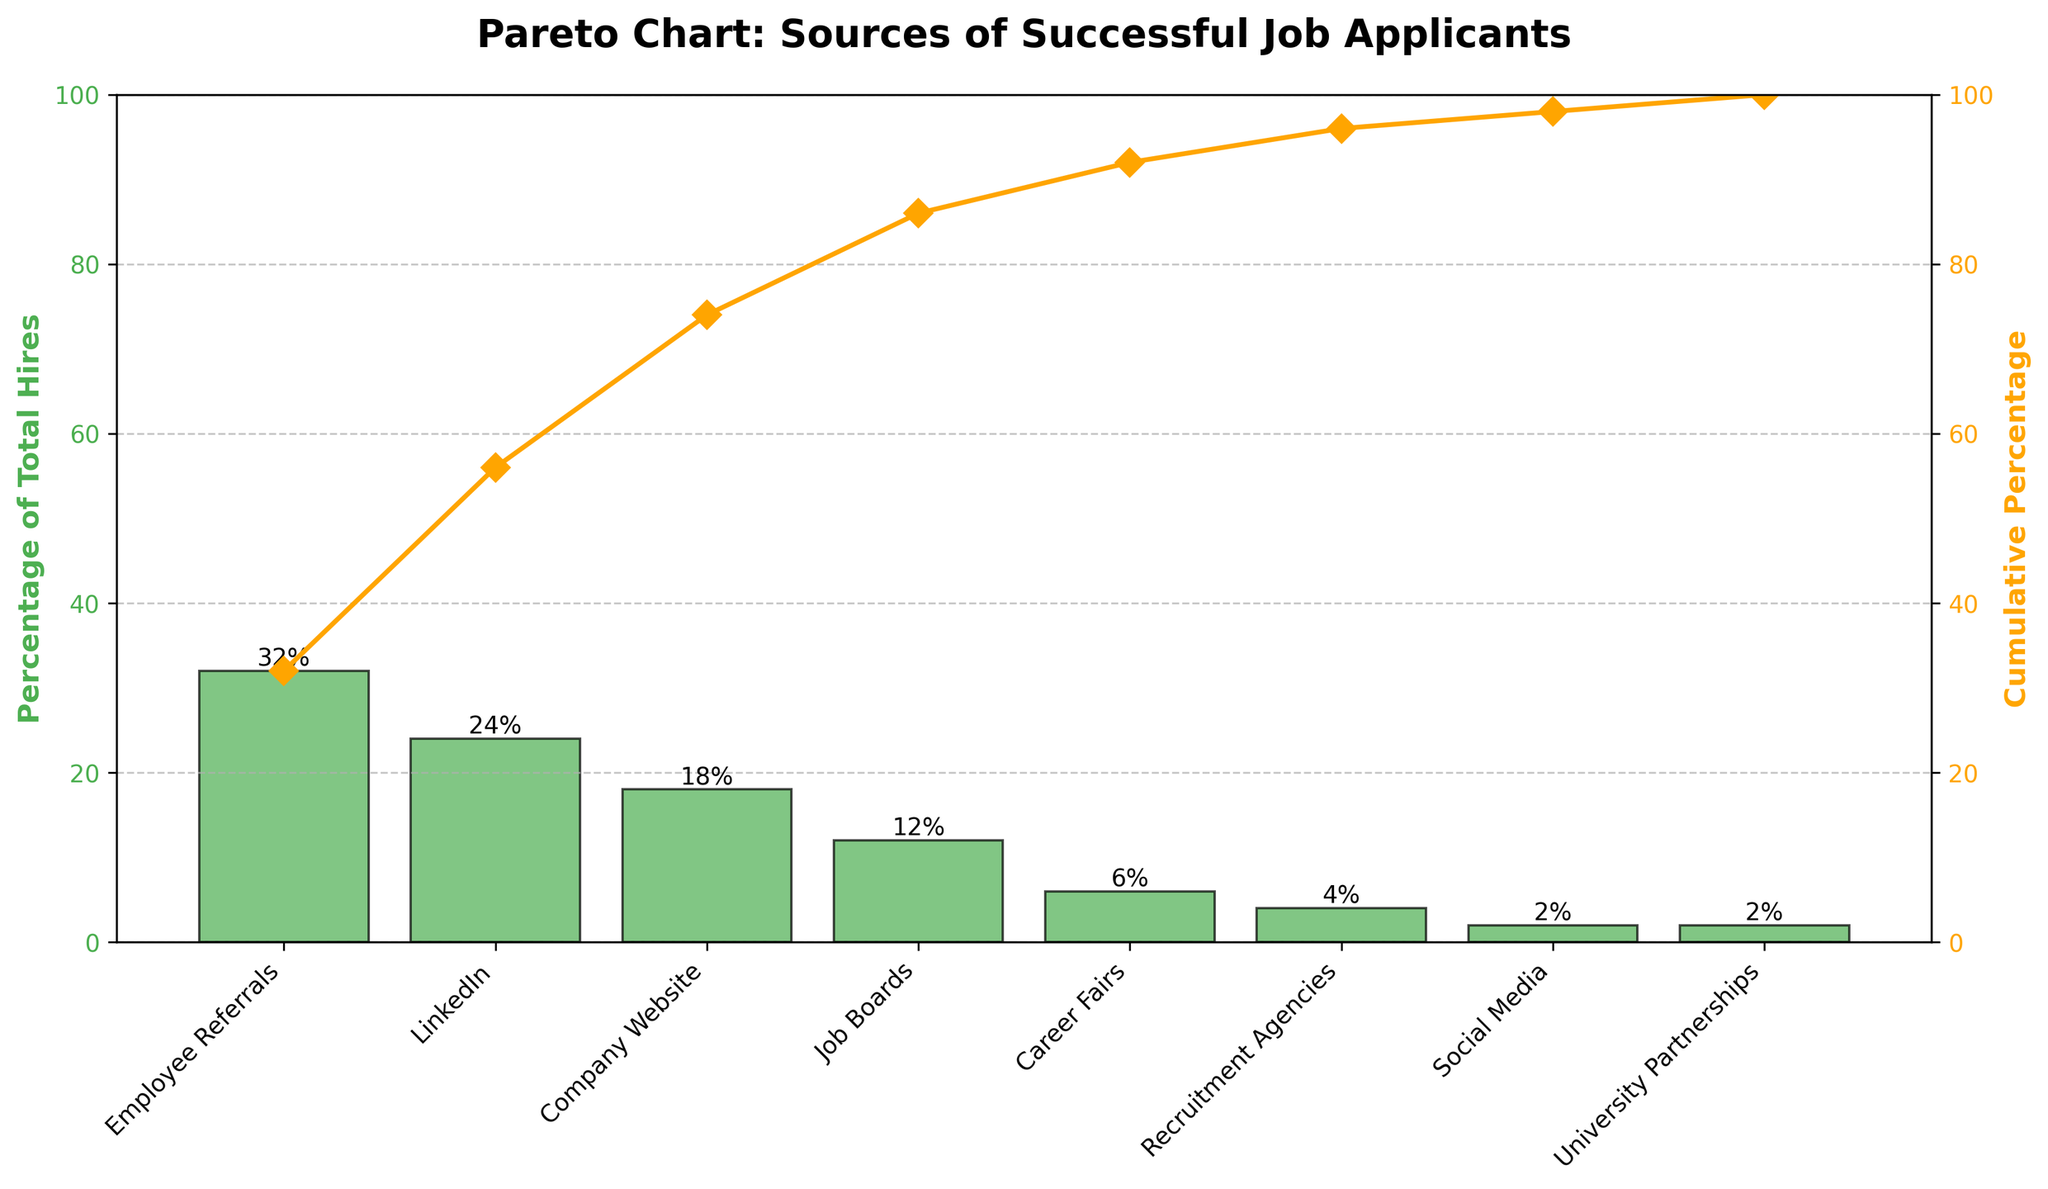How many sources of successful job applicants are shown in the chart? Count the number of bars in the bar chart representing each source of successful job applicants.
Answer: 8 What is the highest percentage source of successful job applicants? Identify the bar with the greatest height representing the highest percentage value, which is labeled on top.
Answer: Employee Referrals What is the cumulative percentage for the top three sources of successful job applicants? Sum the percentages of the top three sources: Employee Referrals (32%), LinkedIn (24%), and Company Website (18%). Then look at the cumulative percentage line for the third source.
Answer: 74% Which source contributes exactly 12% to the total hires? Locate the bar that corresponds to the 12% value as indicated on top of the bar.
Answer: Job Boards What is the cumulative percentage for all the sources combined? Check the cumulative percentage line at the last data point, University Partnerships.
Answer: 100% Which sources combined make up exactly 20% of the total hires? Find the sources whose percentages sum up to 20%. Social Media (2%) + University Partnerships (2%) + Recruitment Agencies (4%) + Career Fairs (6%) + Job Boards (12%) = 26%, which is too much. Recruitment Agencies (4%) + Career Fairs (6%) + Job Boards (12%) = 22%, which is also too much. Just Career Fairs (6%) and Job Boards (12%) is closest.
Answer: Job Boards and Career Fairs By how much does the percentage of hires from Employee Referrals exceed that from Job Boards? Subtract the percentage of Job Boards (12%) from the percentage of Employee Referrals (32%).
Answer: 20% What is the combined percentage for sources with less than 5% contribution individually? Sum the percentages of Recruitment Agencies (4%), Social Media (2%), and University Partnerships (2%).
Answer: 8% Which source directly follows LinkedIn in terms of the number of hires? Identify the source with the next highest bar after LinkedIn.
Answer: Company Website Which source has a similar percentage to Social Media? Find another source with a percentage value close to 2%.
Answer: University Partnerships 